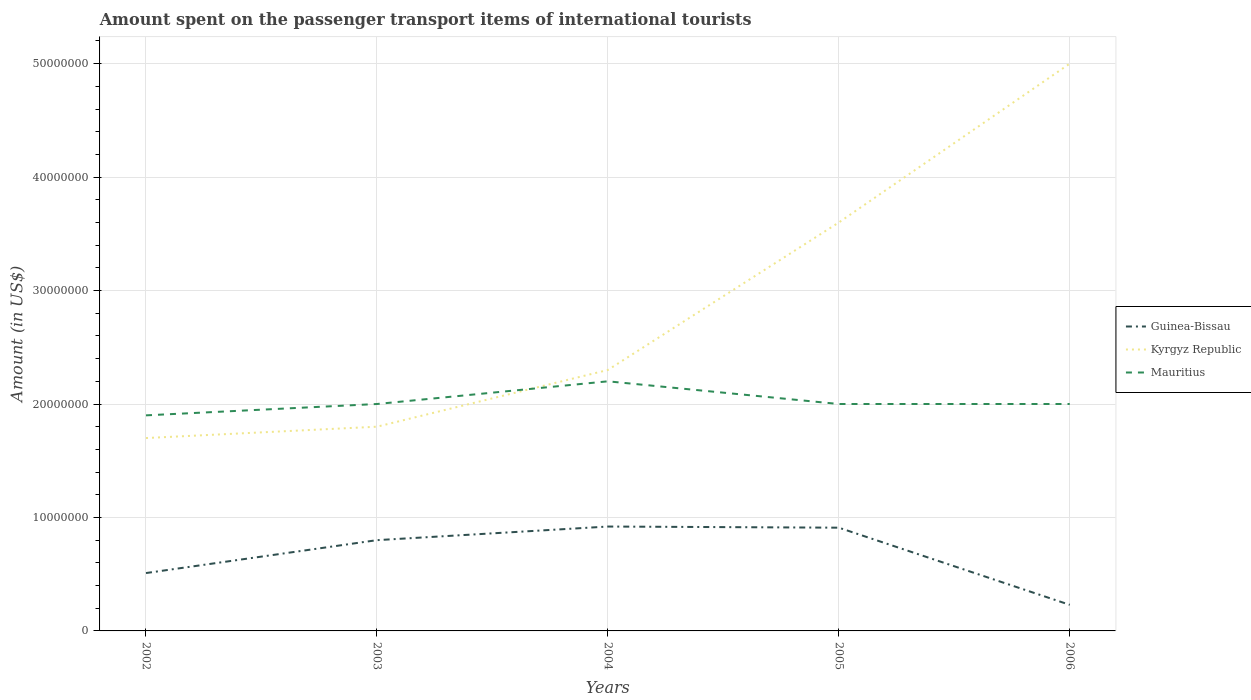How many different coloured lines are there?
Offer a terse response. 3. Does the line corresponding to Kyrgyz Republic intersect with the line corresponding to Mauritius?
Offer a very short reply. Yes. Is the number of lines equal to the number of legend labels?
Provide a short and direct response. Yes. Across all years, what is the maximum amount spent on the passenger transport items of international tourists in Guinea-Bissau?
Provide a short and direct response. 2.30e+06. What is the total amount spent on the passenger transport items of international tourists in Mauritius in the graph?
Offer a very short reply. -1.00e+06. What is the difference between the highest and the second highest amount spent on the passenger transport items of international tourists in Mauritius?
Your response must be concise. 3.00e+06. What is the difference between the highest and the lowest amount spent on the passenger transport items of international tourists in Mauritius?
Give a very brief answer. 1. Is the amount spent on the passenger transport items of international tourists in Mauritius strictly greater than the amount spent on the passenger transport items of international tourists in Kyrgyz Republic over the years?
Offer a very short reply. No. How many years are there in the graph?
Your answer should be very brief. 5. What is the difference between two consecutive major ticks on the Y-axis?
Provide a succinct answer. 1.00e+07. Are the values on the major ticks of Y-axis written in scientific E-notation?
Keep it short and to the point. No. Does the graph contain grids?
Provide a short and direct response. Yes. What is the title of the graph?
Provide a short and direct response. Amount spent on the passenger transport items of international tourists. Does "Oman" appear as one of the legend labels in the graph?
Ensure brevity in your answer.  No. What is the label or title of the Y-axis?
Make the answer very short. Amount (in US$). What is the Amount (in US$) of Guinea-Bissau in 2002?
Offer a very short reply. 5.10e+06. What is the Amount (in US$) in Kyrgyz Republic in 2002?
Give a very brief answer. 1.70e+07. What is the Amount (in US$) in Mauritius in 2002?
Offer a terse response. 1.90e+07. What is the Amount (in US$) of Guinea-Bissau in 2003?
Make the answer very short. 8.00e+06. What is the Amount (in US$) in Kyrgyz Republic in 2003?
Your response must be concise. 1.80e+07. What is the Amount (in US$) in Guinea-Bissau in 2004?
Provide a short and direct response. 9.20e+06. What is the Amount (in US$) in Kyrgyz Republic in 2004?
Make the answer very short. 2.30e+07. What is the Amount (in US$) of Mauritius in 2004?
Provide a succinct answer. 2.20e+07. What is the Amount (in US$) in Guinea-Bissau in 2005?
Your answer should be very brief. 9.10e+06. What is the Amount (in US$) of Kyrgyz Republic in 2005?
Your answer should be very brief. 3.60e+07. What is the Amount (in US$) of Mauritius in 2005?
Your answer should be compact. 2.00e+07. What is the Amount (in US$) in Guinea-Bissau in 2006?
Your answer should be very brief. 2.30e+06. Across all years, what is the maximum Amount (in US$) in Guinea-Bissau?
Ensure brevity in your answer.  9.20e+06. Across all years, what is the maximum Amount (in US$) of Mauritius?
Provide a succinct answer. 2.20e+07. Across all years, what is the minimum Amount (in US$) in Guinea-Bissau?
Keep it short and to the point. 2.30e+06. Across all years, what is the minimum Amount (in US$) in Kyrgyz Republic?
Your response must be concise. 1.70e+07. Across all years, what is the minimum Amount (in US$) in Mauritius?
Provide a succinct answer. 1.90e+07. What is the total Amount (in US$) of Guinea-Bissau in the graph?
Provide a short and direct response. 3.37e+07. What is the total Amount (in US$) of Kyrgyz Republic in the graph?
Offer a very short reply. 1.44e+08. What is the total Amount (in US$) of Mauritius in the graph?
Ensure brevity in your answer.  1.01e+08. What is the difference between the Amount (in US$) of Guinea-Bissau in 2002 and that in 2003?
Provide a succinct answer. -2.90e+06. What is the difference between the Amount (in US$) of Kyrgyz Republic in 2002 and that in 2003?
Provide a succinct answer. -1.00e+06. What is the difference between the Amount (in US$) in Mauritius in 2002 and that in 2003?
Make the answer very short. -1.00e+06. What is the difference between the Amount (in US$) of Guinea-Bissau in 2002 and that in 2004?
Provide a succinct answer. -4.10e+06. What is the difference between the Amount (in US$) of Kyrgyz Republic in 2002 and that in 2004?
Ensure brevity in your answer.  -6.00e+06. What is the difference between the Amount (in US$) of Mauritius in 2002 and that in 2004?
Offer a terse response. -3.00e+06. What is the difference between the Amount (in US$) of Kyrgyz Republic in 2002 and that in 2005?
Make the answer very short. -1.90e+07. What is the difference between the Amount (in US$) in Mauritius in 2002 and that in 2005?
Offer a terse response. -1.00e+06. What is the difference between the Amount (in US$) in Guinea-Bissau in 2002 and that in 2006?
Offer a very short reply. 2.80e+06. What is the difference between the Amount (in US$) of Kyrgyz Republic in 2002 and that in 2006?
Your answer should be compact. -3.30e+07. What is the difference between the Amount (in US$) of Guinea-Bissau in 2003 and that in 2004?
Keep it short and to the point. -1.20e+06. What is the difference between the Amount (in US$) of Kyrgyz Republic in 2003 and that in 2004?
Your answer should be very brief. -5.00e+06. What is the difference between the Amount (in US$) in Guinea-Bissau in 2003 and that in 2005?
Make the answer very short. -1.10e+06. What is the difference between the Amount (in US$) in Kyrgyz Republic in 2003 and that in 2005?
Your answer should be very brief. -1.80e+07. What is the difference between the Amount (in US$) in Guinea-Bissau in 2003 and that in 2006?
Ensure brevity in your answer.  5.70e+06. What is the difference between the Amount (in US$) of Kyrgyz Republic in 2003 and that in 2006?
Your answer should be compact. -3.20e+07. What is the difference between the Amount (in US$) of Mauritius in 2003 and that in 2006?
Provide a succinct answer. 0. What is the difference between the Amount (in US$) in Guinea-Bissau in 2004 and that in 2005?
Make the answer very short. 1.00e+05. What is the difference between the Amount (in US$) in Kyrgyz Republic in 2004 and that in 2005?
Give a very brief answer. -1.30e+07. What is the difference between the Amount (in US$) of Guinea-Bissau in 2004 and that in 2006?
Give a very brief answer. 6.90e+06. What is the difference between the Amount (in US$) in Kyrgyz Republic in 2004 and that in 2006?
Your answer should be very brief. -2.70e+07. What is the difference between the Amount (in US$) in Guinea-Bissau in 2005 and that in 2006?
Make the answer very short. 6.80e+06. What is the difference between the Amount (in US$) of Kyrgyz Republic in 2005 and that in 2006?
Provide a succinct answer. -1.40e+07. What is the difference between the Amount (in US$) of Mauritius in 2005 and that in 2006?
Make the answer very short. 0. What is the difference between the Amount (in US$) in Guinea-Bissau in 2002 and the Amount (in US$) in Kyrgyz Republic in 2003?
Make the answer very short. -1.29e+07. What is the difference between the Amount (in US$) in Guinea-Bissau in 2002 and the Amount (in US$) in Mauritius in 2003?
Offer a very short reply. -1.49e+07. What is the difference between the Amount (in US$) in Kyrgyz Republic in 2002 and the Amount (in US$) in Mauritius in 2003?
Offer a terse response. -3.00e+06. What is the difference between the Amount (in US$) of Guinea-Bissau in 2002 and the Amount (in US$) of Kyrgyz Republic in 2004?
Keep it short and to the point. -1.79e+07. What is the difference between the Amount (in US$) of Guinea-Bissau in 2002 and the Amount (in US$) of Mauritius in 2004?
Your response must be concise. -1.69e+07. What is the difference between the Amount (in US$) in Kyrgyz Republic in 2002 and the Amount (in US$) in Mauritius in 2004?
Ensure brevity in your answer.  -5.00e+06. What is the difference between the Amount (in US$) in Guinea-Bissau in 2002 and the Amount (in US$) in Kyrgyz Republic in 2005?
Offer a very short reply. -3.09e+07. What is the difference between the Amount (in US$) of Guinea-Bissau in 2002 and the Amount (in US$) of Mauritius in 2005?
Provide a short and direct response. -1.49e+07. What is the difference between the Amount (in US$) of Kyrgyz Republic in 2002 and the Amount (in US$) of Mauritius in 2005?
Your response must be concise. -3.00e+06. What is the difference between the Amount (in US$) of Guinea-Bissau in 2002 and the Amount (in US$) of Kyrgyz Republic in 2006?
Your answer should be compact. -4.49e+07. What is the difference between the Amount (in US$) in Guinea-Bissau in 2002 and the Amount (in US$) in Mauritius in 2006?
Offer a terse response. -1.49e+07. What is the difference between the Amount (in US$) in Guinea-Bissau in 2003 and the Amount (in US$) in Kyrgyz Republic in 2004?
Your answer should be compact. -1.50e+07. What is the difference between the Amount (in US$) in Guinea-Bissau in 2003 and the Amount (in US$) in Mauritius in 2004?
Provide a short and direct response. -1.40e+07. What is the difference between the Amount (in US$) of Guinea-Bissau in 2003 and the Amount (in US$) of Kyrgyz Republic in 2005?
Offer a very short reply. -2.80e+07. What is the difference between the Amount (in US$) of Guinea-Bissau in 2003 and the Amount (in US$) of Mauritius in 2005?
Provide a short and direct response. -1.20e+07. What is the difference between the Amount (in US$) in Kyrgyz Republic in 2003 and the Amount (in US$) in Mauritius in 2005?
Ensure brevity in your answer.  -2.00e+06. What is the difference between the Amount (in US$) in Guinea-Bissau in 2003 and the Amount (in US$) in Kyrgyz Republic in 2006?
Your answer should be very brief. -4.20e+07. What is the difference between the Amount (in US$) in Guinea-Bissau in 2003 and the Amount (in US$) in Mauritius in 2006?
Offer a terse response. -1.20e+07. What is the difference between the Amount (in US$) in Kyrgyz Republic in 2003 and the Amount (in US$) in Mauritius in 2006?
Provide a short and direct response. -2.00e+06. What is the difference between the Amount (in US$) in Guinea-Bissau in 2004 and the Amount (in US$) in Kyrgyz Republic in 2005?
Give a very brief answer. -2.68e+07. What is the difference between the Amount (in US$) in Guinea-Bissau in 2004 and the Amount (in US$) in Mauritius in 2005?
Offer a very short reply. -1.08e+07. What is the difference between the Amount (in US$) in Kyrgyz Republic in 2004 and the Amount (in US$) in Mauritius in 2005?
Offer a terse response. 3.00e+06. What is the difference between the Amount (in US$) of Guinea-Bissau in 2004 and the Amount (in US$) of Kyrgyz Republic in 2006?
Provide a short and direct response. -4.08e+07. What is the difference between the Amount (in US$) in Guinea-Bissau in 2004 and the Amount (in US$) in Mauritius in 2006?
Your response must be concise. -1.08e+07. What is the difference between the Amount (in US$) of Kyrgyz Republic in 2004 and the Amount (in US$) of Mauritius in 2006?
Give a very brief answer. 3.00e+06. What is the difference between the Amount (in US$) in Guinea-Bissau in 2005 and the Amount (in US$) in Kyrgyz Republic in 2006?
Offer a very short reply. -4.09e+07. What is the difference between the Amount (in US$) in Guinea-Bissau in 2005 and the Amount (in US$) in Mauritius in 2006?
Your response must be concise. -1.09e+07. What is the difference between the Amount (in US$) of Kyrgyz Republic in 2005 and the Amount (in US$) of Mauritius in 2006?
Your answer should be very brief. 1.60e+07. What is the average Amount (in US$) of Guinea-Bissau per year?
Ensure brevity in your answer.  6.74e+06. What is the average Amount (in US$) in Kyrgyz Republic per year?
Make the answer very short. 2.88e+07. What is the average Amount (in US$) in Mauritius per year?
Provide a short and direct response. 2.02e+07. In the year 2002, what is the difference between the Amount (in US$) of Guinea-Bissau and Amount (in US$) of Kyrgyz Republic?
Your response must be concise. -1.19e+07. In the year 2002, what is the difference between the Amount (in US$) in Guinea-Bissau and Amount (in US$) in Mauritius?
Give a very brief answer. -1.39e+07. In the year 2003, what is the difference between the Amount (in US$) of Guinea-Bissau and Amount (in US$) of Kyrgyz Republic?
Give a very brief answer. -1.00e+07. In the year 2003, what is the difference between the Amount (in US$) in Guinea-Bissau and Amount (in US$) in Mauritius?
Give a very brief answer. -1.20e+07. In the year 2003, what is the difference between the Amount (in US$) of Kyrgyz Republic and Amount (in US$) of Mauritius?
Provide a succinct answer. -2.00e+06. In the year 2004, what is the difference between the Amount (in US$) in Guinea-Bissau and Amount (in US$) in Kyrgyz Republic?
Your response must be concise. -1.38e+07. In the year 2004, what is the difference between the Amount (in US$) in Guinea-Bissau and Amount (in US$) in Mauritius?
Keep it short and to the point. -1.28e+07. In the year 2005, what is the difference between the Amount (in US$) of Guinea-Bissau and Amount (in US$) of Kyrgyz Republic?
Your response must be concise. -2.69e+07. In the year 2005, what is the difference between the Amount (in US$) of Guinea-Bissau and Amount (in US$) of Mauritius?
Provide a short and direct response. -1.09e+07. In the year 2005, what is the difference between the Amount (in US$) in Kyrgyz Republic and Amount (in US$) in Mauritius?
Offer a very short reply. 1.60e+07. In the year 2006, what is the difference between the Amount (in US$) in Guinea-Bissau and Amount (in US$) in Kyrgyz Republic?
Your answer should be compact. -4.77e+07. In the year 2006, what is the difference between the Amount (in US$) of Guinea-Bissau and Amount (in US$) of Mauritius?
Give a very brief answer. -1.77e+07. In the year 2006, what is the difference between the Amount (in US$) in Kyrgyz Republic and Amount (in US$) in Mauritius?
Your answer should be very brief. 3.00e+07. What is the ratio of the Amount (in US$) in Guinea-Bissau in 2002 to that in 2003?
Provide a short and direct response. 0.64. What is the ratio of the Amount (in US$) in Kyrgyz Republic in 2002 to that in 2003?
Keep it short and to the point. 0.94. What is the ratio of the Amount (in US$) of Guinea-Bissau in 2002 to that in 2004?
Ensure brevity in your answer.  0.55. What is the ratio of the Amount (in US$) in Kyrgyz Republic in 2002 to that in 2004?
Your response must be concise. 0.74. What is the ratio of the Amount (in US$) of Mauritius in 2002 to that in 2004?
Offer a very short reply. 0.86. What is the ratio of the Amount (in US$) of Guinea-Bissau in 2002 to that in 2005?
Provide a succinct answer. 0.56. What is the ratio of the Amount (in US$) of Kyrgyz Republic in 2002 to that in 2005?
Offer a very short reply. 0.47. What is the ratio of the Amount (in US$) of Guinea-Bissau in 2002 to that in 2006?
Provide a succinct answer. 2.22. What is the ratio of the Amount (in US$) of Kyrgyz Republic in 2002 to that in 2006?
Provide a succinct answer. 0.34. What is the ratio of the Amount (in US$) of Guinea-Bissau in 2003 to that in 2004?
Make the answer very short. 0.87. What is the ratio of the Amount (in US$) in Kyrgyz Republic in 2003 to that in 2004?
Give a very brief answer. 0.78. What is the ratio of the Amount (in US$) in Guinea-Bissau in 2003 to that in 2005?
Your answer should be compact. 0.88. What is the ratio of the Amount (in US$) in Guinea-Bissau in 2003 to that in 2006?
Make the answer very short. 3.48. What is the ratio of the Amount (in US$) of Kyrgyz Republic in 2003 to that in 2006?
Provide a succinct answer. 0.36. What is the ratio of the Amount (in US$) in Mauritius in 2003 to that in 2006?
Keep it short and to the point. 1. What is the ratio of the Amount (in US$) in Kyrgyz Republic in 2004 to that in 2005?
Provide a succinct answer. 0.64. What is the ratio of the Amount (in US$) of Guinea-Bissau in 2004 to that in 2006?
Provide a short and direct response. 4. What is the ratio of the Amount (in US$) in Kyrgyz Republic in 2004 to that in 2006?
Keep it short and to the point. 0.46. What is the ratio of the Amount (in US$) of Guinea-Bissau in 2005 to that in 2006?
Offer a terse response. 3.96. What is the ratio of the Amount (in US$) of Kyrgyz Republic in 2005 to that in 2006?
Give a very brief answer. 0.72. What is the difference between the highest and the second highest Amount (in US$) in Kyrgyz Republic?
Offer a very short reply. 1.40e+07. What is the difference between the highest and the second highest Amount (in US$) of Mauritius?
Give a very brief answer. 2.00e+06. What is the difference between the highest and the lowest Amount (in US$) in Guinea-Bissau?
Make the answer very short. 6.90e+06. What is the difference between the highest and the lowest Amount (in US$) of Kyrgyz Republic?
Offer a very short reply. 3.30e+07. 